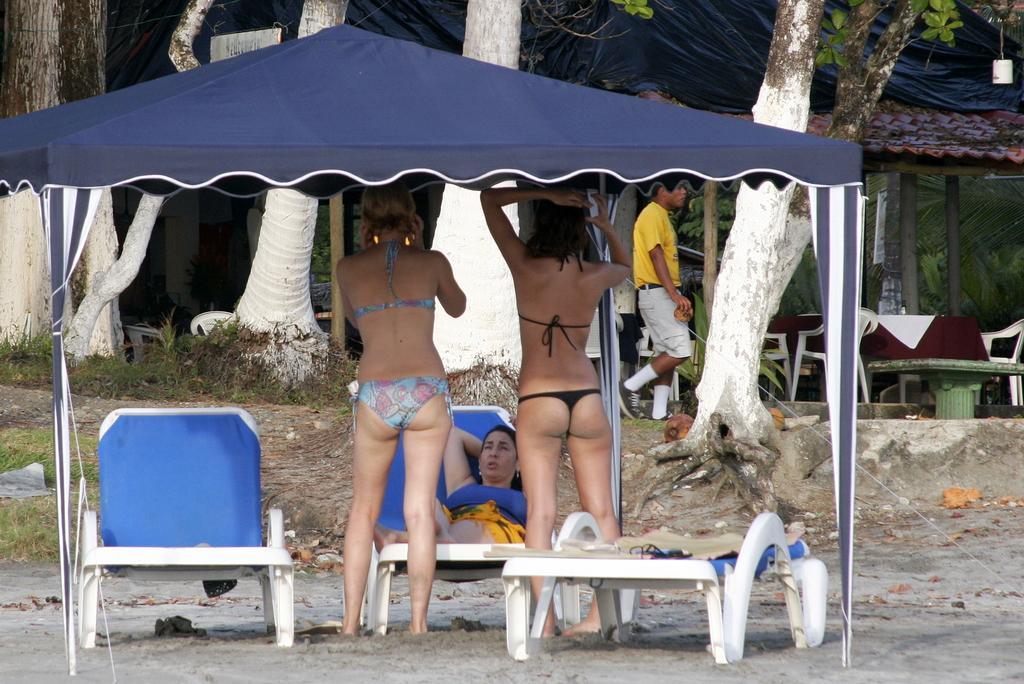Please provide a concise description of this image. In this picture we can see four people were two women standing on the ground, woman sitting on a chair, man walking, tent, chairs, table, trees and in the background we can see a sheet on a rooftop. 